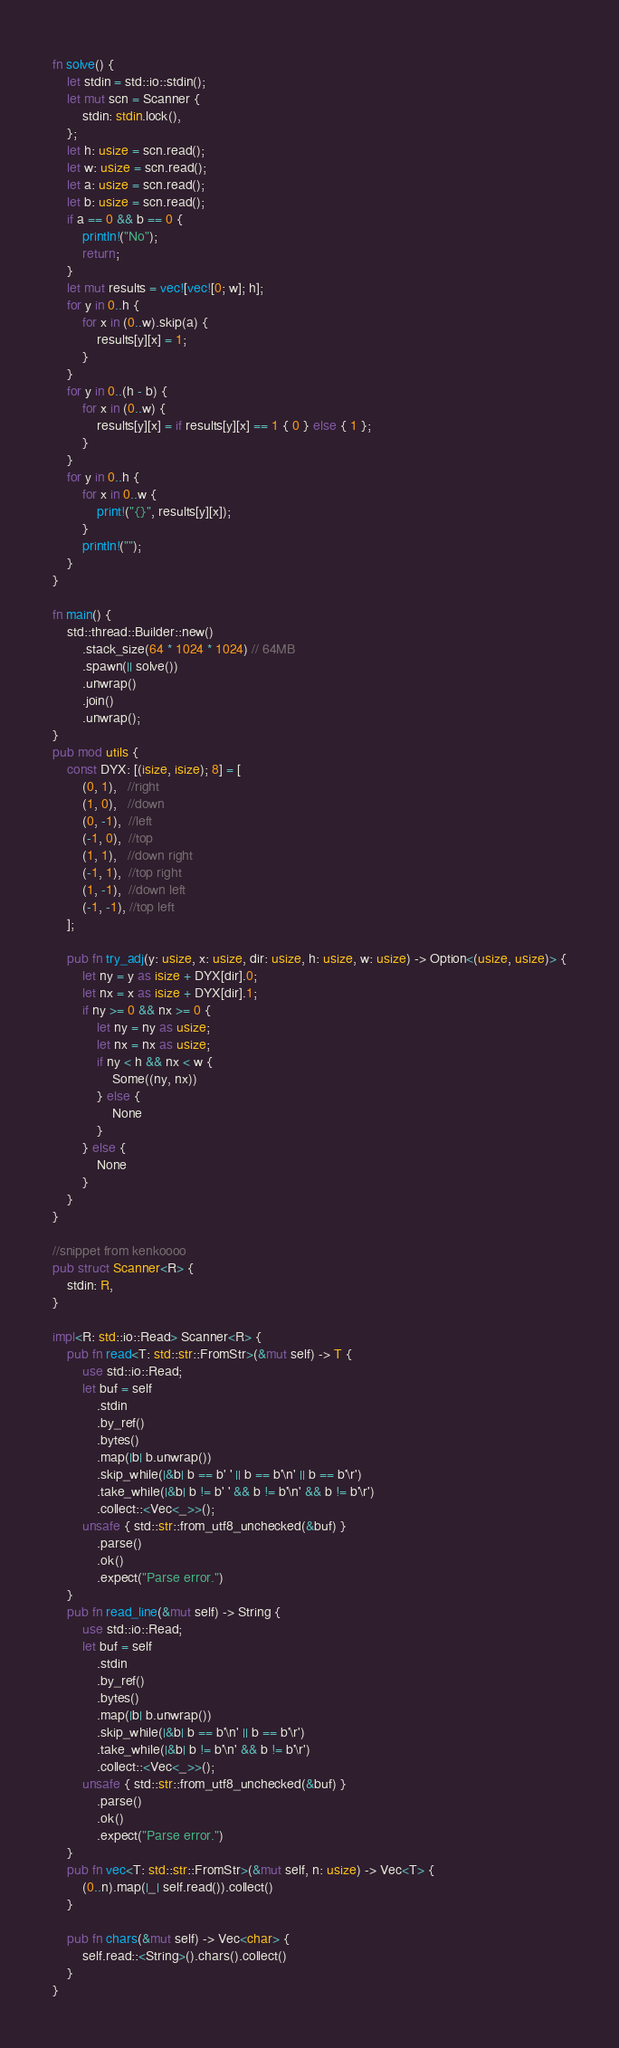Convert code to text. <code><loc_0><loc_0><loc_500><loc_500><_Rust_>fn solve() {
    let stdin = std::io::stdin();
    let mut scn = Scanner {
        stdin: stdin.lock(),
    };
    let h: usize = scn.read();
    let w: usize = scn.read();
    let a: usize = scn.read();
    let b: usize = scn.read();
    if a == 0 && b == 0 {
        println!("No");
        return;
    }
    let mut results = vec![vec![0; w]; h];
    for y in 0..h {
        for x in (0..w).skip(a) {
            results[y][x] = 1;
        }
    }
    for y in 0..(h - b) {
        for x in (0..w) {
            results[y][x] = if results[y][x] == 1 { 0 } else { 1 };
        }
    }
    for y in 0..h {
        for x in 0..w {
            print!("{}", results[y][x]);
        }
        println!("");
    }
}

fn main() {
    std::thread::Builder::new()
        .stack_size(64 * 1024 * 1024) // 64MB
        .spawn(|| solve())
        .unwrap()
        .join()
        .unwrap();
}
pub mod utils {
    const DYX: [(isize, isize); 8] = [
        (0, 1),   //right
        (1, 0),   //down
        (0, -1),  //left
        (-1, 0),  //top
        (1, 1),   //down right
        (-1, 1),  //top right
        (1, -1),  //down left
        (-1, -1), //top left
    ];

    pub fn try_adj(y: usize, x: usize, dir: usize, h: usize, w: usize) -> Option<(usize, usize)> {
        let ny = y as isize + DYX[dir].0;
        let nx = x as isize + DYX[dir].1;
        if ny >= 0 && nx >= 0 {
            let ny = ny as usize;
            let nx = nx as usize;
            if ny < h && nx < w {
                Some((ny, nx))
            } else {
                None
            }
        } else {
            None
        }
    }
}

//snippet from kenkoooo
pub struct Scanner<R> {
    stdin: R,
}

impl<R: std::io::Read> Scanner<R> {
    pub fn read<T: std::str::FromStr>(&mut self) -> T {
        use std::io::Read;
        let buf = self
            .stdin
            .by_ref()
            .bytes()
            .map(|b| b.unwrap())
            .skip_while(|&b| b == b' ' || b == b'\n' || b == b'\r')
            .take_while(|&b| b != b' ' && b != b'\n' && b != b'\r')
            .collect::<Vec<_>>();
        unsafe { std::str::from_utf8_unchecked(&buf) }
            .parse()
            .ok()
            .expect("Parse error.")
    }
    pub fn read_line(&mut self) -> String {
        use std::io::Read;
        let buf = self
            .stdin
            .by_ref()
            .bytes()
            .map(|b| b.unwrap())
            .skip_while(|&b| b == b'\n' || b == b'\r')
            .take_while(|&b| b != b'\n' && b != b'\r')
            .collect::<Vec<_>>();
        unsafe { std::str::from_utf8_unchecked(&buf) }
            .parse()
            .ok()
            .expect("Parse error.")
    }
    pub fn vec<T: std::str::FromStr>(&mut self, n: usize) -> Vec<T> {
        (0..n).map(|_| self.read()).collect()
    }

    pub fn chars(&mut self) -> Vec<char> {
        self.read::<String>().chars().collect()
    }
}
</code> 